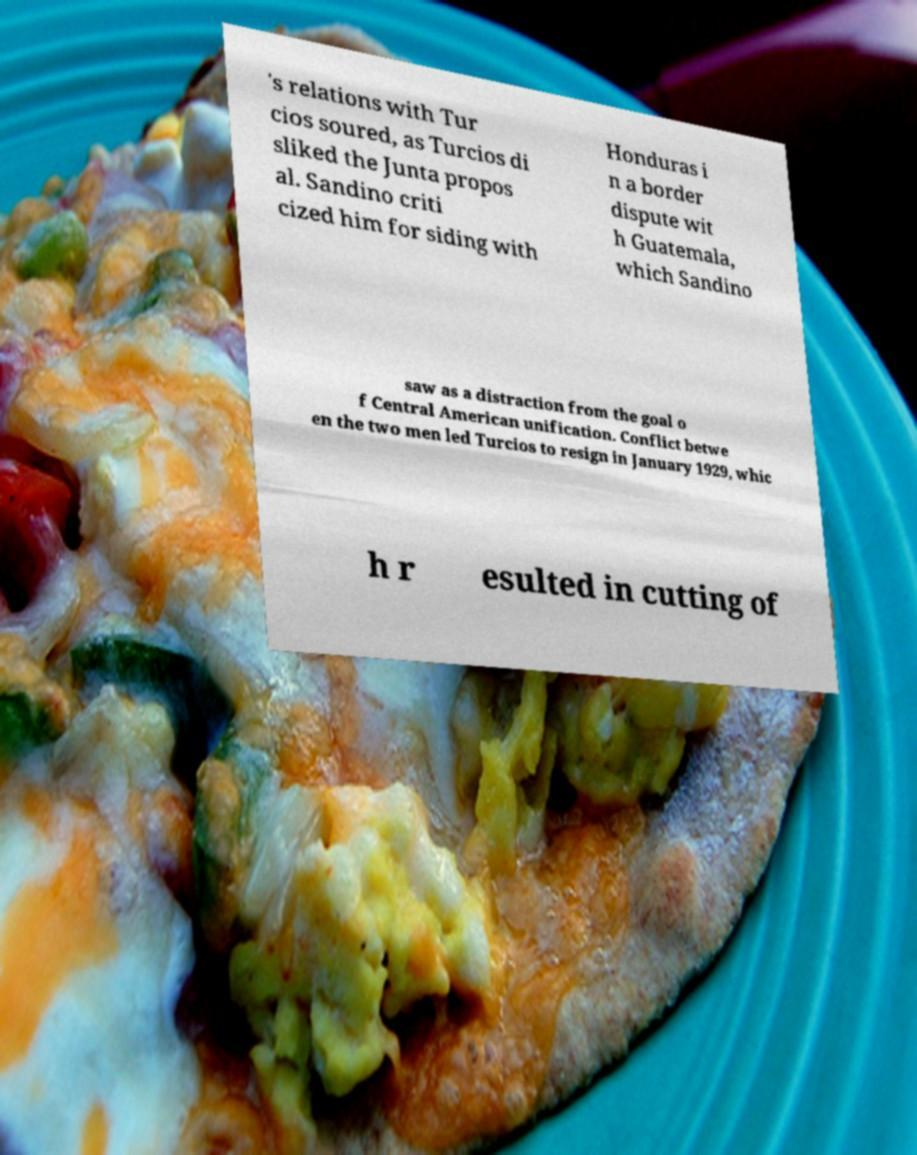I need the written content from this picture converted into text. Can you do that? 's relations with Tur cios soured, as Turcios di sliked the Junta propos al. Sandino criti cized him for siding with Honduras i n a border dispute wit h Guatemala, which Sandino saw as a distraction from the goal o f Central American unification. Conflict betwe en the two men led Turcios to resign in January 1929, whic h r esulted in cutting of 